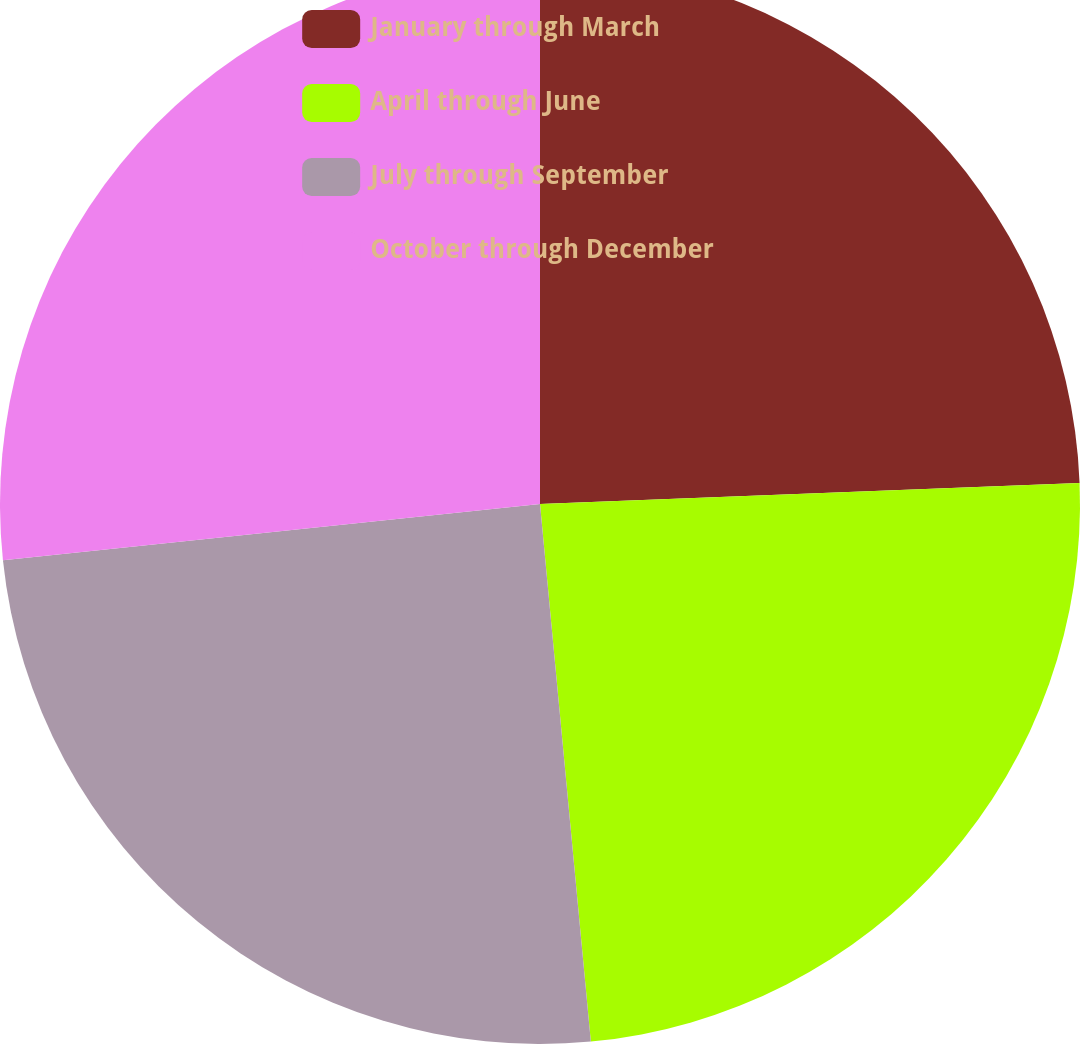<chart> <loc_0><loc_0><loc_500><loc_500><pie_chart><fcel>January through March<fcel>April through June<fcel>July through September<fcel>October through December<nl><fcel>24.38%<fcel>24.12%<fcel>24.84%<fcel>26.66%<nl></chart> 